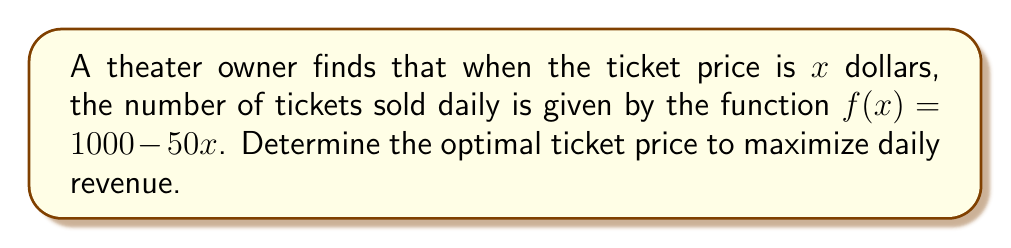What is the answer to this math problem? 1. The revenue function $R(x)$ is the product of the ticket price $x$ and the number of tickets sold $f(x)$:
   $$R(x) = x \cdot f(x) = x(1000 - 50x) = 1000x - 50x^2$$

2. To find the maximum revenue, we need to find the critical point of $R(x)$. We do this by taking the derivative of $R(x)$ and setting it equal to zero:
   $$R'(x) = 1000 - 100x$$
   $$1000 - 100x = 0$$

3. Solve for $x$:
   $$100x = 1000$$
   $$x = 10$$

4. To confirm this is a maximum, we can check the second derivative:
   $$R''(x) = -100$$
   Since $R''(x)$ is negative, the critical point is indeed a maximum.

5. Therefore, the optimal ticket price is $10 dollars.

6. We can verify the revenue at this price:
   $$R(10) = 1000(10) - 50(10)^2 = 10000 - 5000 = 5000$$
   The maximum daily revenue is $5000 dollars.
Answer: $10 